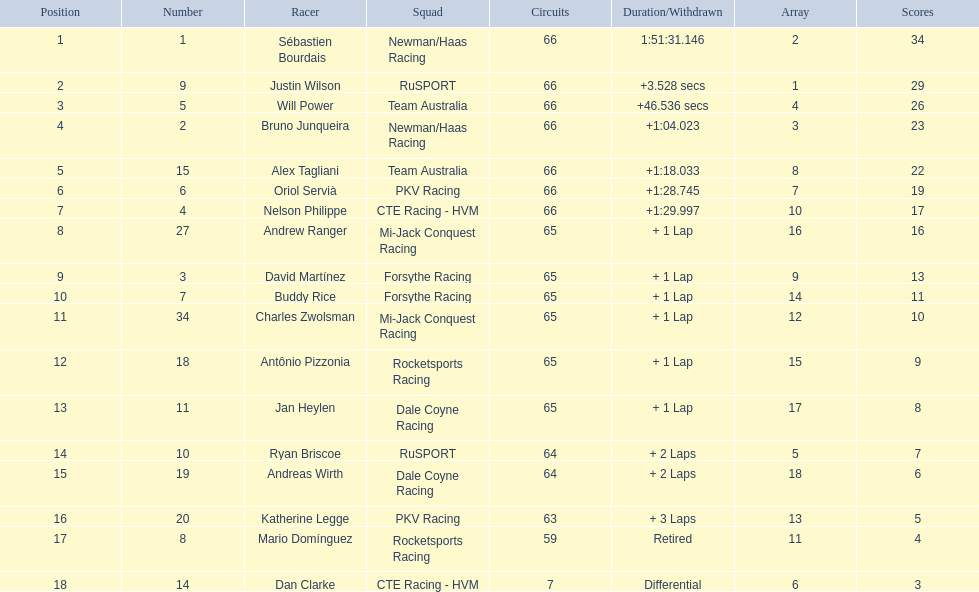Which teams participated in the 2006 gran premio telmex? Newman/Haas Racing, RuSPORT, Team Australia, Newman/Haas Racing, Team Australia, PKV Racing, CTE Racing - HVM, Mi-Jack Conquest Racing, Forsythe Racing, Forsythe Racing, Mi-Jack Conquest Racing, Rocketsports Racing, Dale Coyne Racing, RuSPORT, Dale Coyne Racing, PKV Racing, Rocketsports Racing, CTE Racing - HVM. Who were the drivers of these teams? Sébastien Bourdais, Justin Wilson, Will Power, Bruno Junqueira, Alex Tagliani, Oriol Servià, Nelson Philippe, Andrew Ranger, David Martínez, Buddy Rice, Charles Zwolsman, Antônio Pizzonia, Jan Heylen, Ryan Briscoe, Andreas Wirth, Katherine Legge, Mario Domínguez, Dan Clarke. Parse the full table. {'header': ['Position', 'Number', 'Racer', 'Squad', 'Circuits', 'Duration/Withdrawn', 'Array', 'Scores'], 'rows': [['1', '1', 'Sébastien Bourdais', 'Newman/Haas Racing', '66', '1:51:31.146', '2', '34'], ['2', '9', 'Justin Wilson', 'RuSPORT', '66', '+3.528 secs', '1', '29'], ['3', '5', 'Will Power', 'Team Australia', '66', '+46.536 secs', '4', '26'], ['4', '2', 'Bruno Junqueira', 'Newman/Haas Racing', '66', '+1:04.023', '3', '23'], ['5', '15', 'Alex Tagliani', 'Team Australia', '66', '+1:18.033', '8', '22'], ['6', '6', 'Oriol Servià', 'PKV Racing', '66', '+1:28.745', '7', '19'], ['7', '4', 'Nelson Philippe', 'CTE Racing - HVM', '66', '+1:29.997', '10', '17'], ['8', '27', 'Andrew Ranger', 'Mi-Jack Conquest Racing', '65', '+ 1 Lap', '16', '16'], ['9', '3', 'David Martínez', 'Forsythe Racing', '65', '+ 1 Lap', '9', '13'], ['10', '7', 'Buddy Rice', 'Forsythe Racing', '65', '+ 1 Lap', '14', '11'], ['11', '34', 'Charles Zwolsman', 'Mi-Jack Conquest Racing', '65', '+ 1 Lap', '12', '10'], ['12', '18', 'Antônio Pizzonia', 'Rocketsports Racing', '65', '+ 1 Lap', '15', '9'], ['13', '11', 'Jan Heylen', 'Dale Coyne Racing', '65', '+ 1 Lap', '17', '8'], ['14', '10', 'Ryan Briscoe', 'RuSPORT', '64', '+ 2 Laps', '5', '7'], ['15', '19', 'Andreas Wirth', 'Dale Coyne Racing', '64', '+ 2 Laps', '18', '6'], ['16', '20', 'Katherine Legge', 'PKV Racing', '63', '+ 3 Laps', '13', '5'], ['17', '8', 'Mario Domínguez', 'Rocketsports Racing', '59', 'Retired', '11', '4'], ['18', '14', 'Dan Clarke', 'CTE Racing - HVM', '7', 'Differential', '6', '3']]} Which driver finished last? Dan Clarke. 